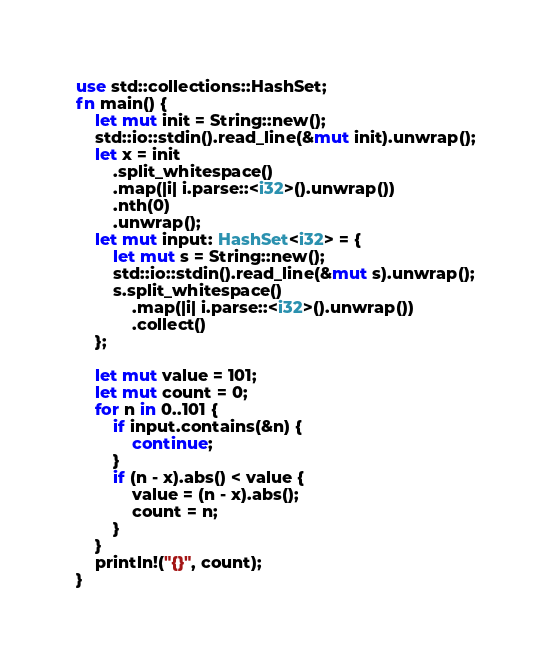<code> <loc_0><loc_0><loc_500><loc_500><_Rust_>use std::collections::HashSet;
fn main() {
    let mut init = String::new();
    std::io::stdin().read_line(&mut init).unwrap();
    let x = init
        .split_whitespace()
        .map(|i| i.parse::<i32>().unwrap())
        .nth(0)
        .unwrap();
    let mut input: HashSet<i32> = {
        let mut s = String::new();
        std::io::stdin().read_line(&mut s).unwrap();
        s.split_whitespace()
            .map(|i| i.parse::<i32>().unwrap())
            .collect()
    };
    
    let mut value = 101;
    let mut count = 0;
    for n in 0..101 {
        if input.contains(&n) {
            continue;
        }
        if (n - x).abs() < value {
            value = (n - x).abs();
            count = n;
        }
    }
    println!("{}", count);
}</code> 